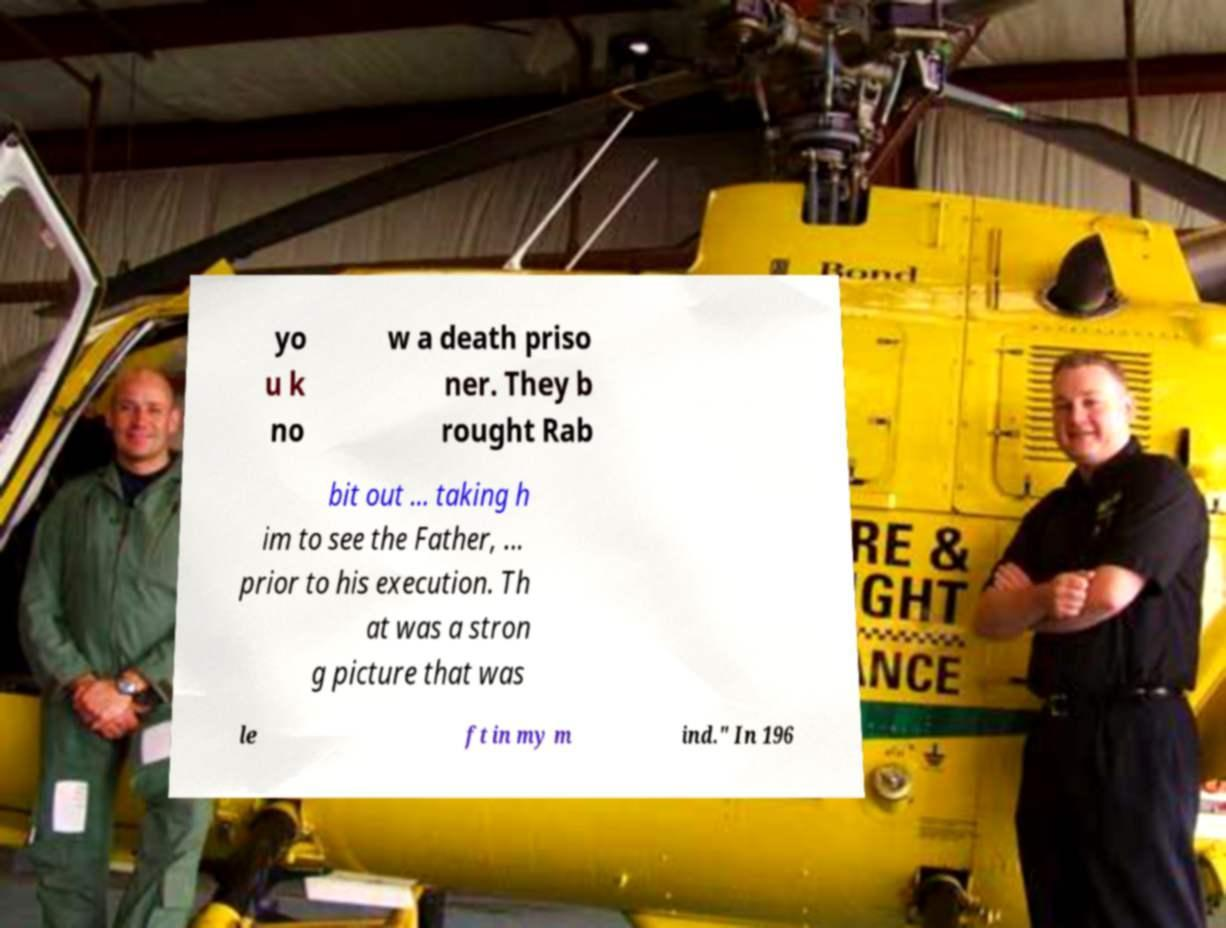Please identify and transcribe the text found in this image. yo u k no w a death priso ner. They b rought Rab bit out ... taking h im to see the Father, ... prior to his execution. Th at was a stron g picture that was le ft in my m ind." In 196 